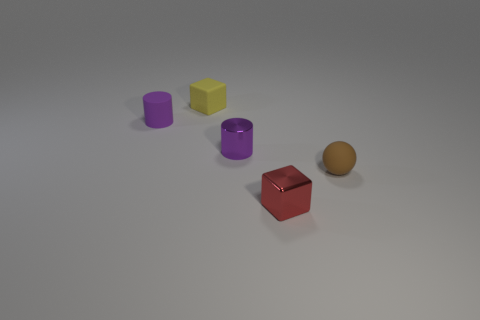What is the shape of the tiny matte object that is both in front of the tiny yellow cube and left of the rubber ball?
Your answer should be compact. Cylinder. There is a tiny cube behind the cylinder that is in front of the purple object that is left of the yellow object; what color is it?
Keep it short and to the point. Yellow. Is the number of rubber objects behind the tiny brown thing greater than the number of yellow matte cubes that are left of the metal block?
Keep it short and to the point. Yes. What number of other objects are there of the same size as the yellow cube?
Offer a terse response. 4. There is a rubber object that is the same color as the tiny metallic cylinder; what is its size?
Offer a terse response. Small. There is a tiny cube behind the tiny matte thing to the right of the small red object; what is its material?
Your answer should be very brief. Rubber. Are there any tiny purple rubber things on the left side of the tiny metallic cube?
Give a very brief answer. Yes. Is the number of purple cylinders to the right of the purple rubber cylinder greater than the number of gray matte cylinders?
Provide a succinct answer. Yes. Are there any cylinders that have the same color as the tiny metal cube?
Make the answer very short. No. What is the color of the metal cylinder that is the same size as the brown rubber thing?
Offer a terse response. Purple. 